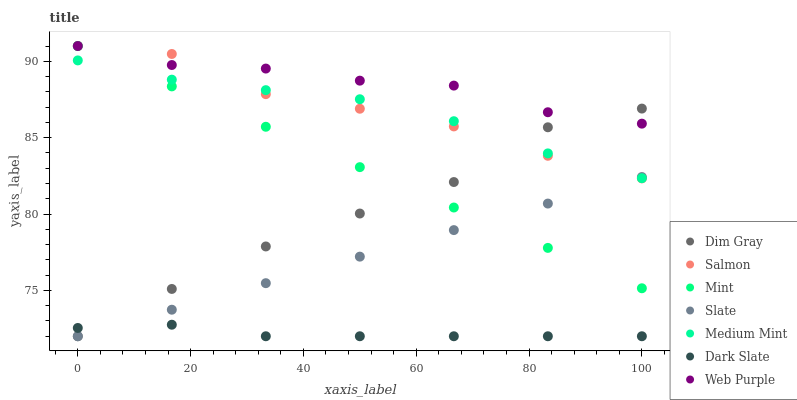Does Dark Slate have the minimum area under the curve?
Answer yes or no. Yes. Does Web Purple have the maximum area under the curve?
Answer yes or no. Yes. Does Dim Gray have the minimum area under the curve?
Answer yes or no. No. Does Dim Gray have the maximum area under the curve?
Answer yes or no. No. Is Mint the smoothest?
Answer yes or no. Yes. Is Salmon the roughest?
Answer yes or no. Yes. Is Dim Gray the smoothest?
Answer yes or no. No. Is Dim Gray the roughest?
Answer yes or no. No. Does Dim Gray have the lowest value?
Answer yes or no. Yes. Does Salmon have the lowest value?
Answer yes or no. No. Does Mint have the highest value?
Answer yes or no. Yes. Does Dim Gray have the highest value?
Answer yes or no. No. Is Slate less than Web Purple?
Answer yes or no. Yes. Is Web Purple greater than Dark Slate?
Answer yes or no. Yes. Does Dim Gray intersect Slate?
Answer yes or no. Yes. Is Dim Gray less than Slate?
Answer yes or no. No. Is Dim Gray greater than Slate?
Answer yes or no. No. Does Slate intersect Web Purple?
Answer yes or no. No. 